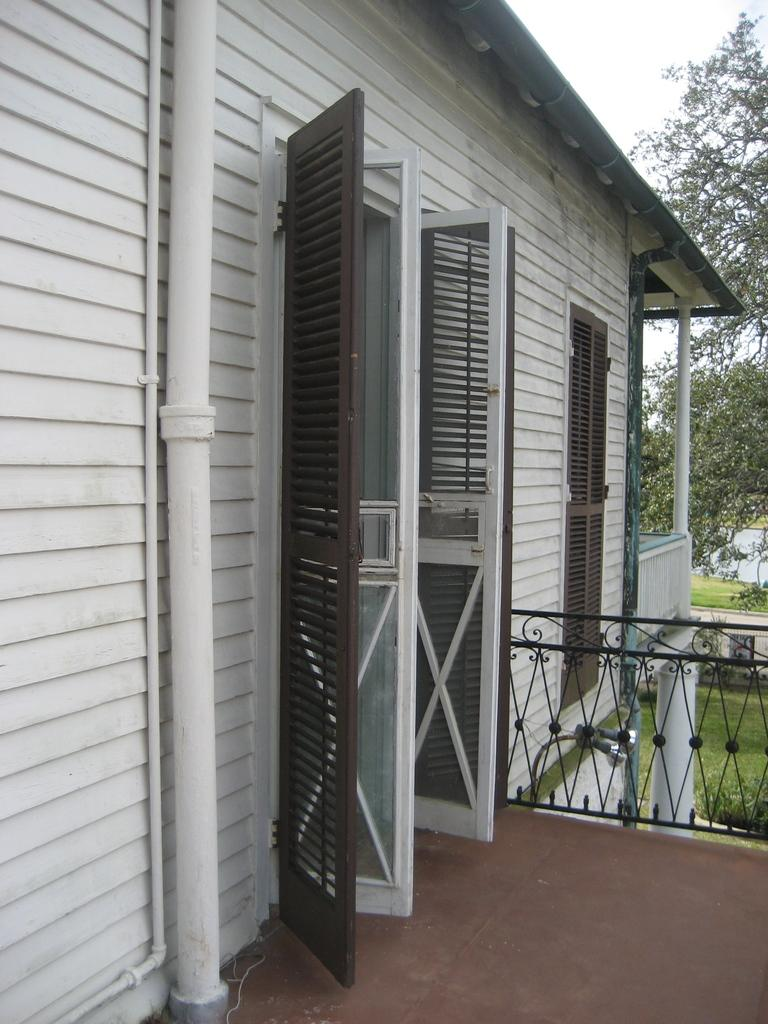What type of structure is in the image? There is a building in the image. What feature of the building is mentioned in the facts? The building has a door. What can be seen behind the building? There are trees behind the building. What type of ground cover is visible in the image? There is grass visible in the image. How many legs can be seen supporting the building in the image? The building is not supported by legs; it is a solid structure. What type of observation can be made about the building's architectural style in the image? The facts provided do not give any information about the building's architectural style, so it cannot be determined from the image. 